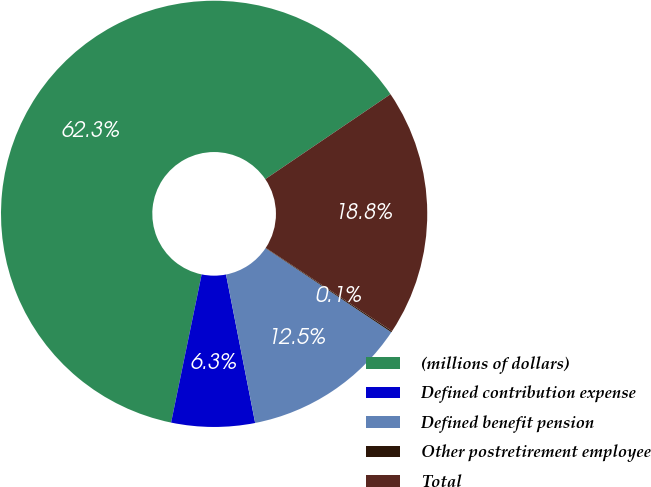<chart> <loc_0><loc_0><loc_500><loc_500><pie_chart><fcel>(millions of dollars)<fcel>Defined contribution expense<fcel>Defined benefit pension<fcel>Other postretirement employee<fcel>Total<nl><fcel>62.28%<fcel>6.32%<fcel>12.54%<fcel>0.1%<fcel>18.76%<nl></chart> 